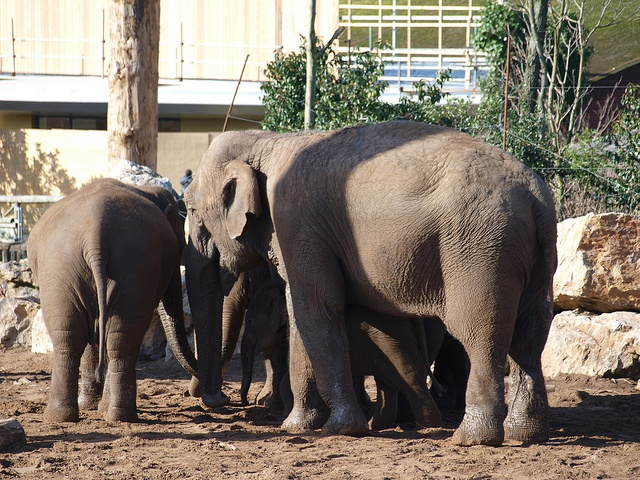Describe the objects in this image and their specific colors. I can see elephant in beige, black, gray, and tan tones, elephant in beige, black, tan, and gray tones, elephant in beige, black, gray, and maroon tones, elephant in beige, black, and gray tones, and people in beige, gray, and darkgray tones in this image. 